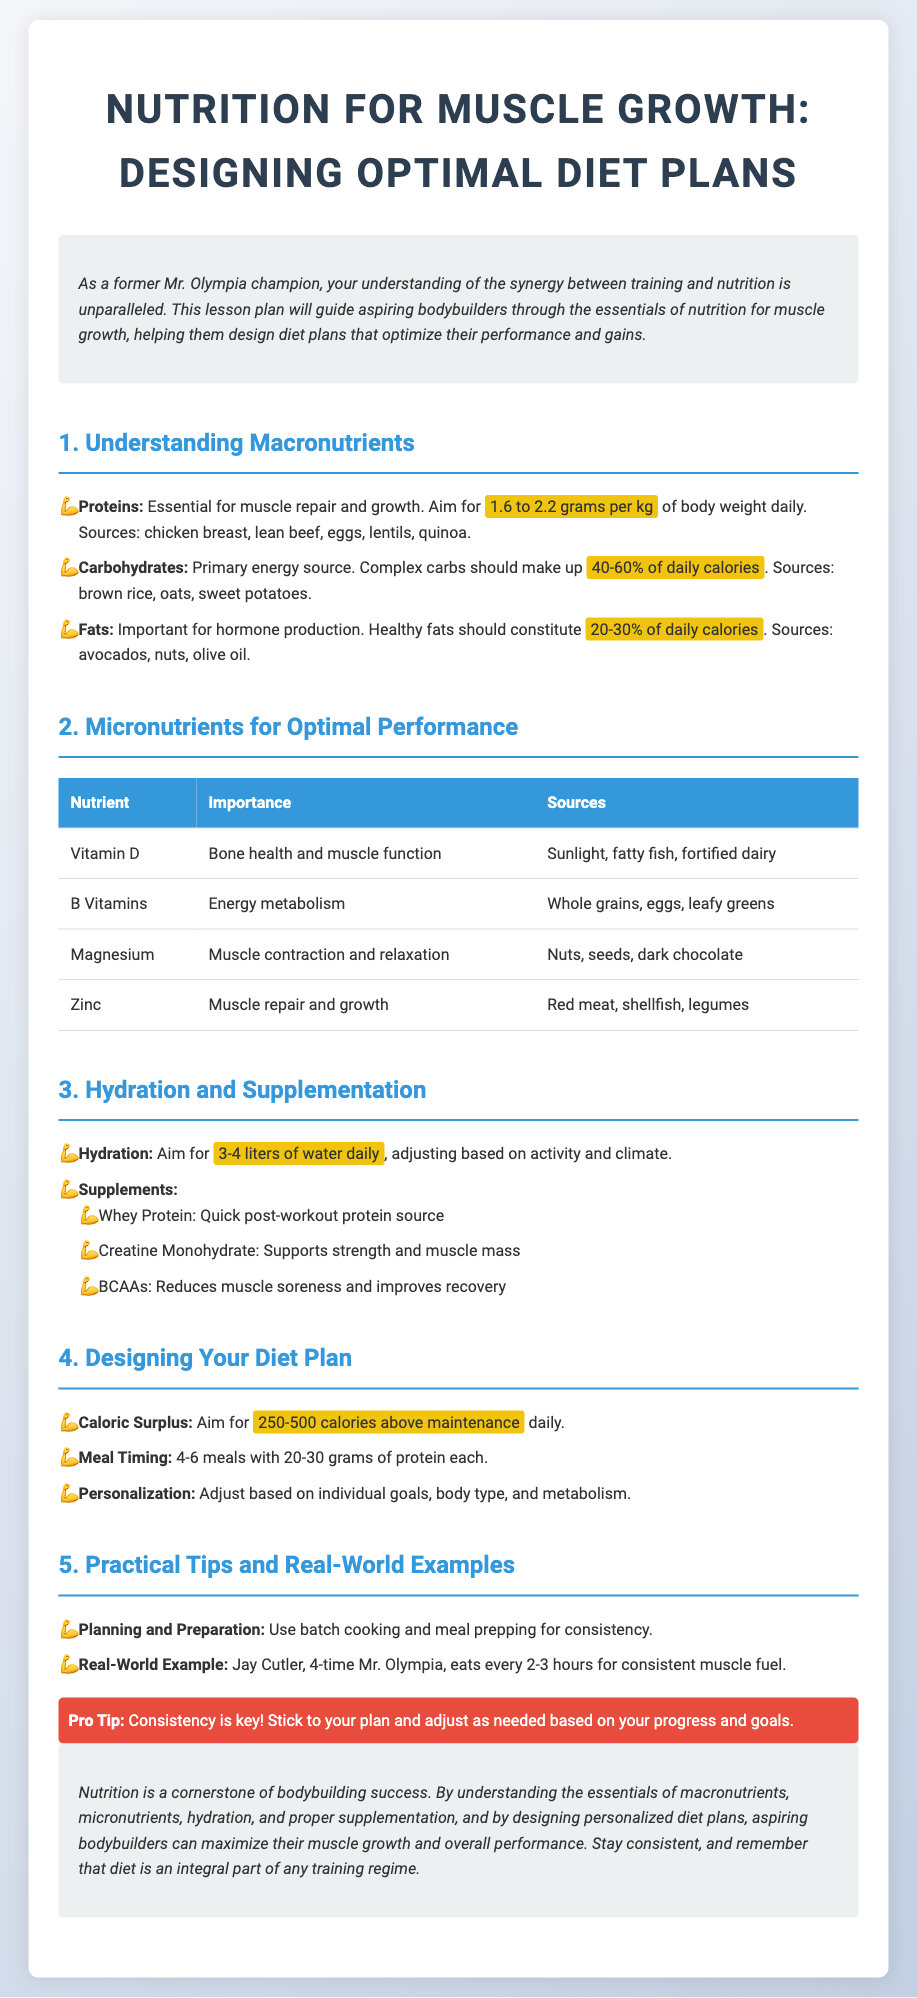What is the recommended protein intake per kg of body weight? The document states that the aim for protein intake is 1.6 to 2.2 grams per kg of body weight daily.
Answer: 1.6 to 2.2 grams What percentage of daily calories should complex carbohydrates make up? According to the document, complex carbohydrates should constitute 40-60% of daily calories.
Answer: 40-60% What nutrient is important for muscle contraction and relaxation? The document lists Magnesium as the nutrient important for muscle contraction and relaxation.
Answer: Magnesium How many liters of water should one aim to drink daily? The lesson plan indicates to aim for 3-4 liters of water daily for hydration.
Answer: 3-4 liters What caloric surplus is suggested for daily intake? The document recommends aiming for 250-500 calories above maintenance daily as a caloric surplus.
Answer: 250-500 calories What is a practical tip for meal consistency? The lesson plan suggests using batch cooking and meal prepping for consistency.
Answer: Batch cooking and meal prepping Which former Mr. Olympia is mentioned for eating every 2-3 hours? The document provides Jay Cutler as an example of a former Mr. Olympia who eats every 2-3 hours.
Answer: Jay Cutler What should make up 20-30% of daily calories? Healthy fats are indicated to constitute 20-30% of daily calories.
Answer: Healthy fats What is the key to bodybuilding success according to the conclusion? The conclusion emphasizes that nutrition is a cornerstone of bodybuilding success.
Answer: Nutrition 